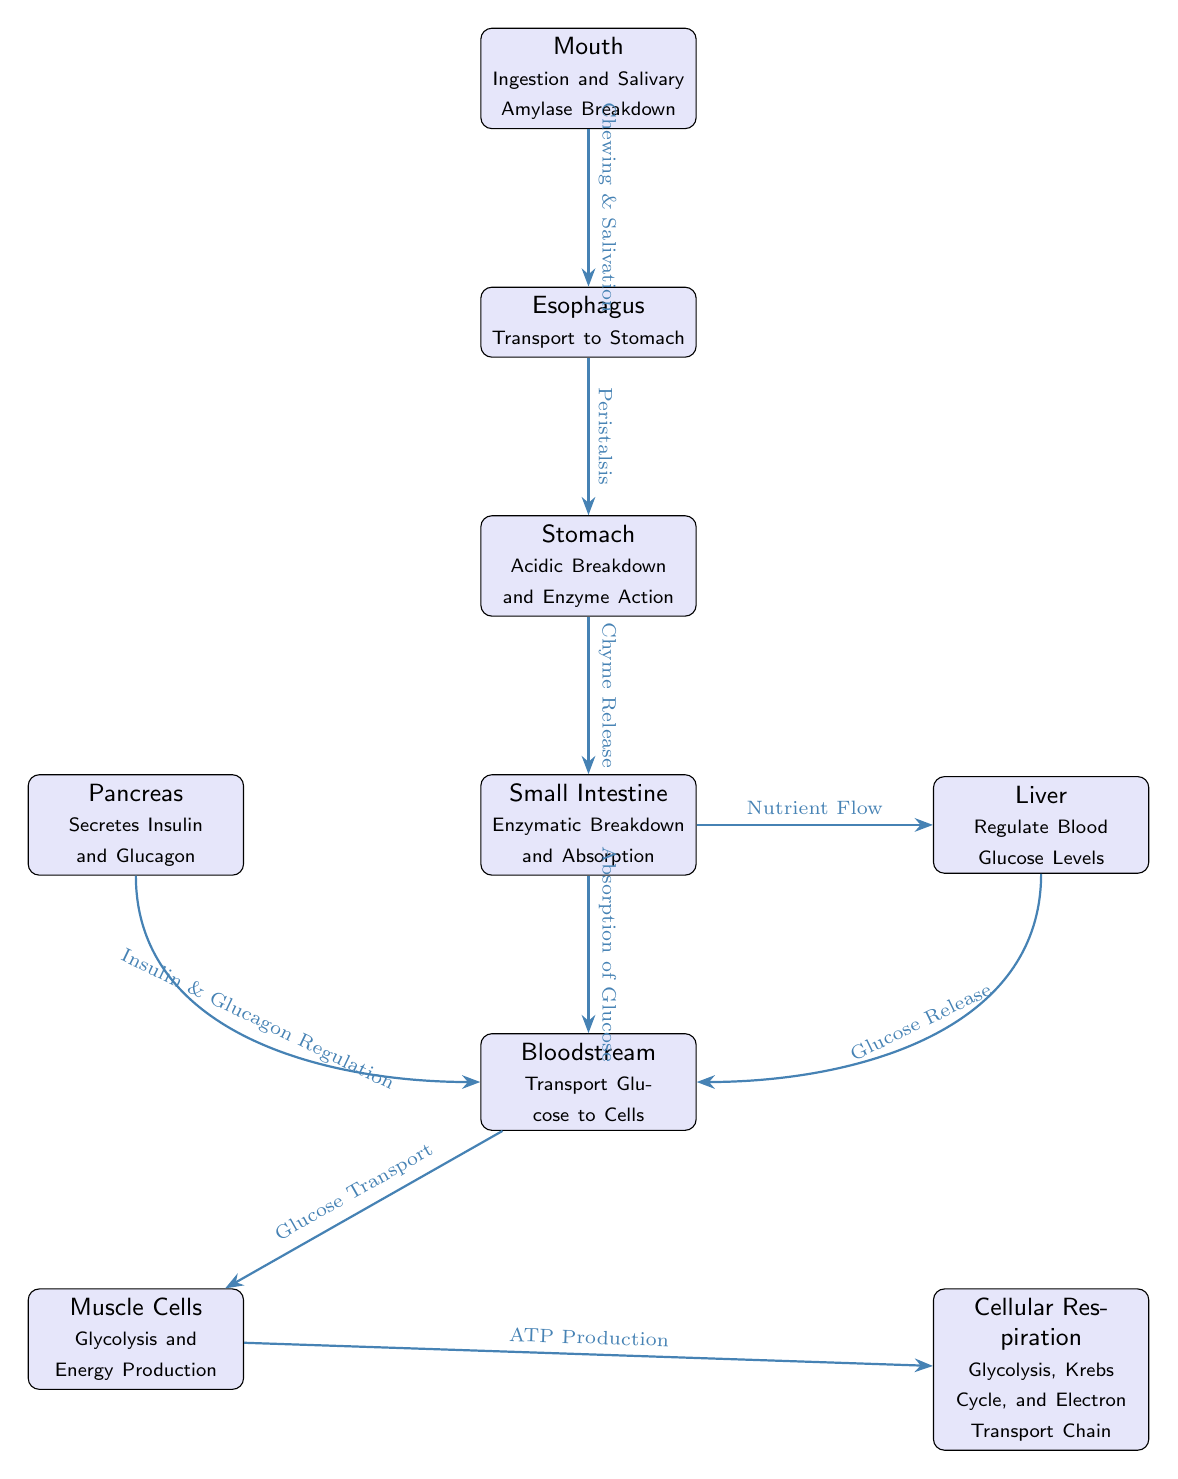What is the first step in glucose metabolism according to the diagram? The diagram indicates that ingestion occurs in the mouth, where glucose metabolism begins with saliva and chewing.
Answer: Mouth Which organ is responsible for regulating blood glucose levels? The liver is shown in the diagram with a note indicating its role in regulating blood glucose levels.
Answer: Liver How does glucose move from the small intestine to the bloodstream? The diagram illustrates that glucose absorption from the small intestine leads directly to the bloodstream.
Answer: Absorption of Glucose What substance does the pancreas secrete to regulate glucose levels? The diagram states that the pancreas secretes insulin and glucagon, which are crucial for glucose regulation.
Answer: Insulin and Glucagon What process occurs in muscle cells after glucose transport? The diagram shows that muscle cells perform glycolysis and ATP production after receiving glucose from the bloodstream.
Answer: Glycolysis and Energy Production Which component is directly below the stomach in the diagram? The diagram places the small intestine directly below the stomach, indicating the flow of digestion.
Answer: Small Intestine What flow from the small intestine also leads to the liver? According to the diagram, the nutrient flow from the small intestine also directs towards the liver for processing.
Answer: Nutrient Flow What is the final process indicated in the diagram related to glucose metabolism? The diagram shows that the final process highlighted is cellular respiration, which includes glycolysis, Krebs Cycle, and Electron Transport Chain.
Answer: Cellular Respiration 